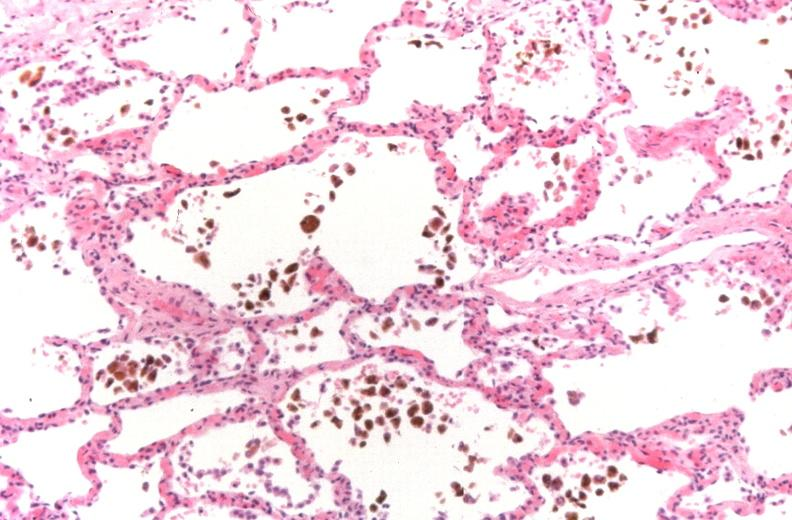s glioblastoma multiforme present?
Answer the question using a single word or phrase. No 